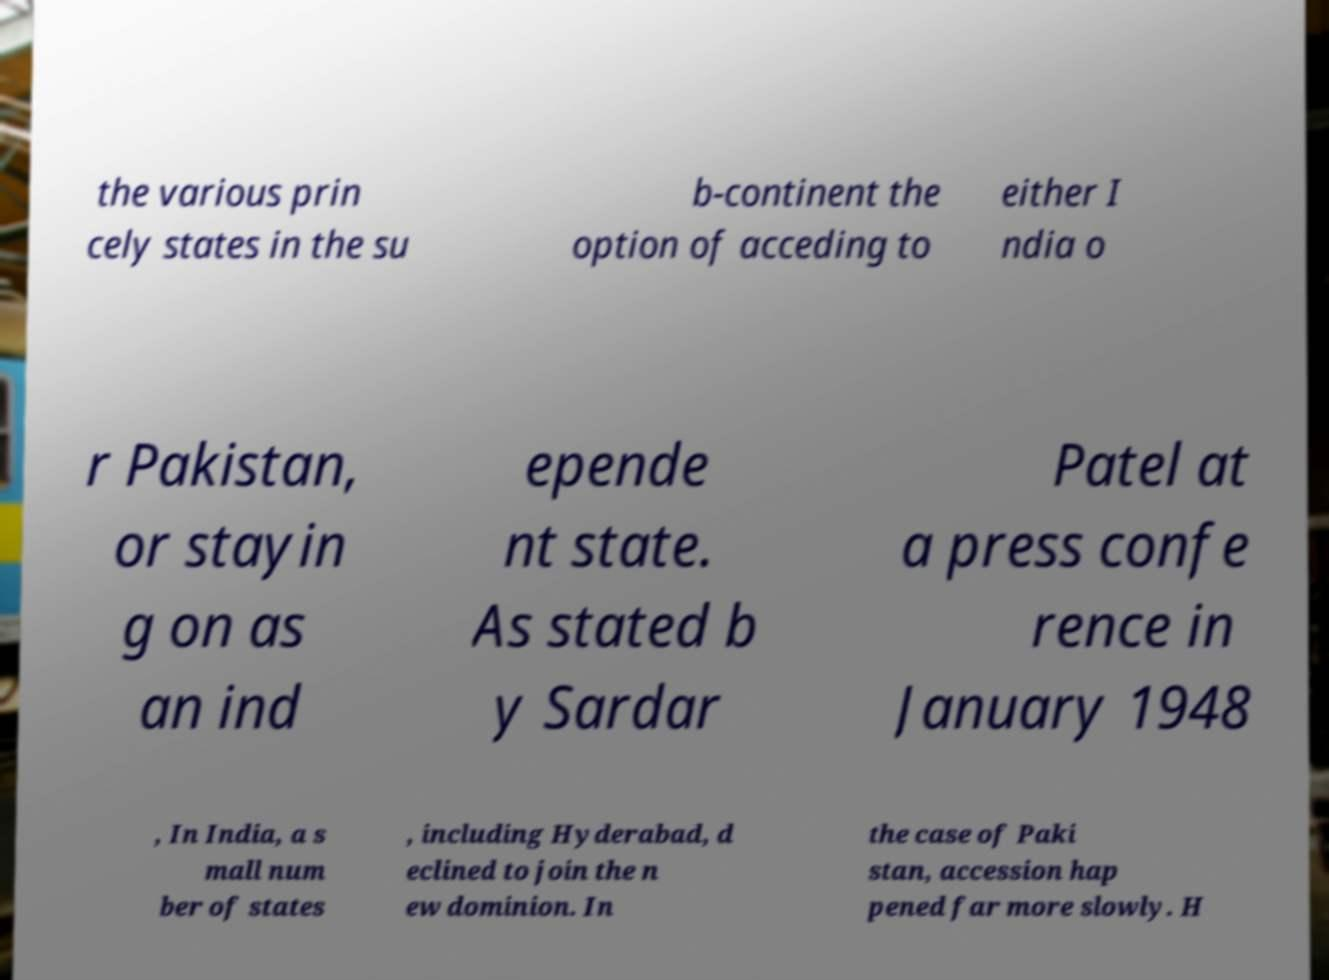Could you extract and type out the text from this image? the various prin cely states in the su b-continent the option of acceding to either I ndia o r Pakistan, or stayin g on as an ind epende nt state. As stated b y Sardar Patel at a press confe rence in January 1948 , In India, a s mall num ber of states , including Hyderabad, d eclined to join the n ew dominion. In the case of Paki stan, accession hap pened far more slowly. H 